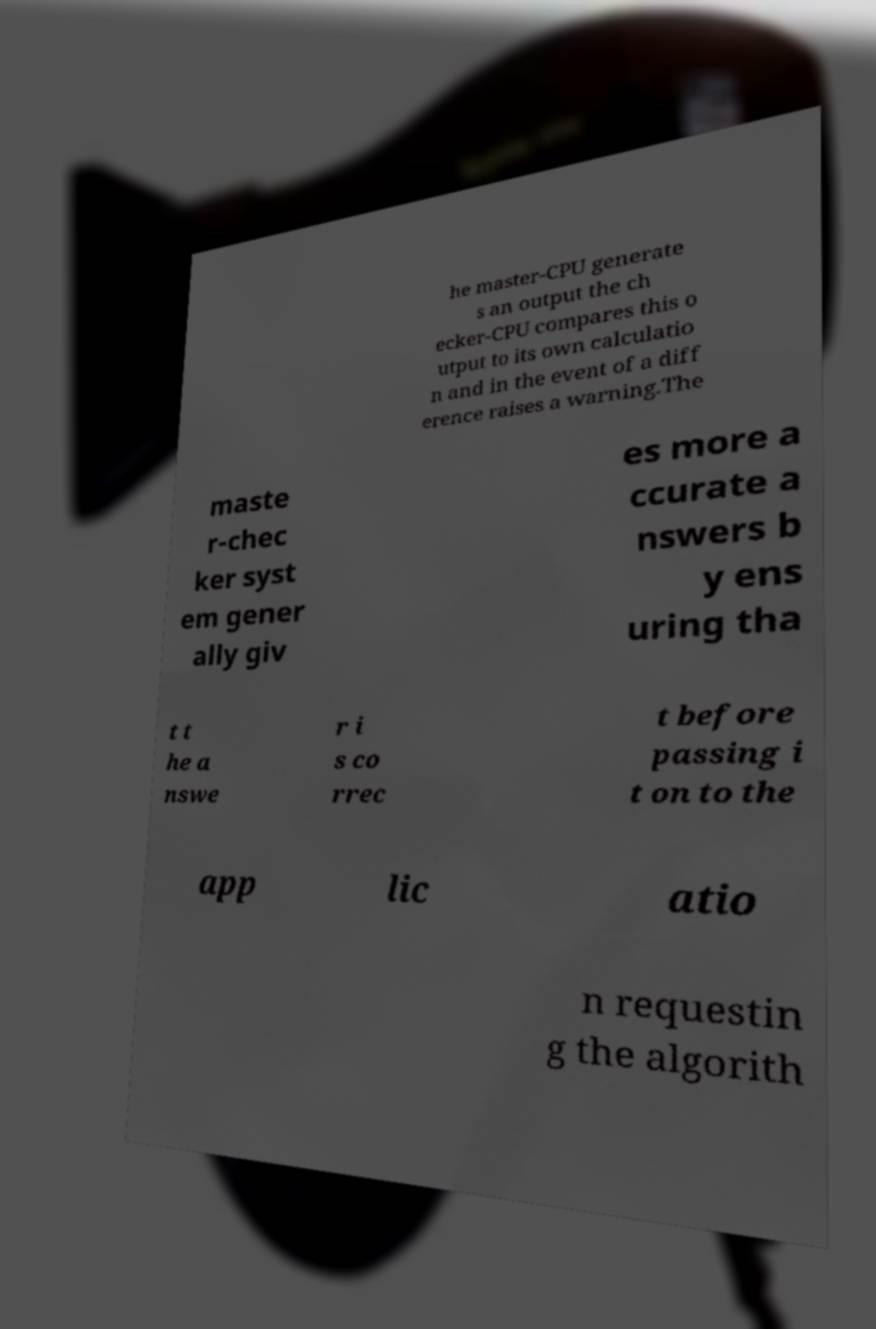Can you accurately transcribe the text from the provided image for me? he master-CPU generate s an output the ch ecker-CPU compares this o utput to its own calculatio n and in the event of a diff erence raises a warning.The maste r-chec ker syst em gener ally giv es more a ccurate a nswers b y ens uring tha t t he a nswe r i s co rrec t before passing i t on to the app lic atio n requestin g the algorith 